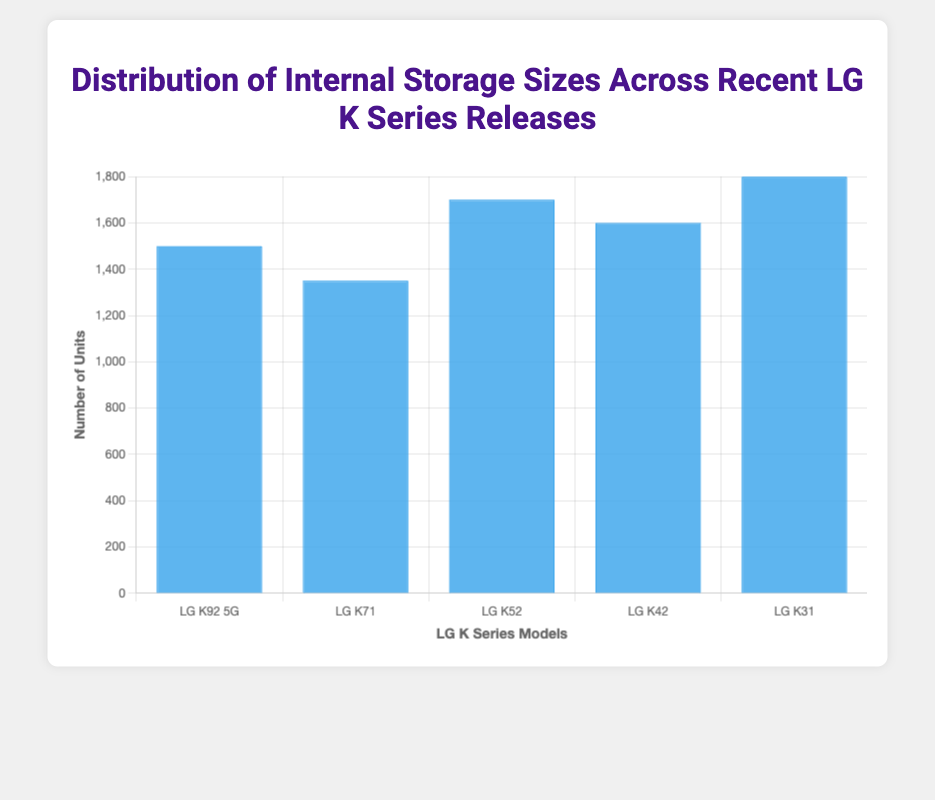Which LG K Series model has the highest number of units with a specific internal storage size? Looking at the height of the bars, the LG K31 with 32GB storage has the highest number of units at 1800.
Answer: LG K31 What is the total number of units for all recent LG K Series releases? Sum the counts of each model: 1500 (LG K92 5G) + 1350 (LG K71) + 1700 (LG K52) + 1600 (LG K42) + 1800 (LG K31) = 7950.
Answer: 7950 Which model has more units, the LG K52 with 64GB storage or the LG K92 5G with 128GB storage? Comparing the two counts, the LG K52 has 1700 units, and the LG K92 5G has 1500 units. Therefore, the LG K52 has more units.
Answer: LG K52 How many more units does the LG K31 have compared to the LG K71? Subtract the count of LG K71 from the count of LG K31: 1800 - 1350 = 450.
Answer: 450 What is the average number of units across all the LG K Series models? Sum the units for all models and divide by the number of models: (1500 + 1350 + 1700 + 1600 + 1800) / 5 = 7950 / 5 = 1590.
Answer: 1590 Which storage size has the most units across all models? Check the count of each storage size: 
- 128GB (LG K92 5G and LG K71): 1500 + 1350 = 2850 
- 64GB (LG K52 and LG K42): 1700 + 1600 = 3300 
- 32GB (LG K31): 1800. The 64GB storage size has the most units at 3300.
Answer: 64GB Is there a model with double or more units compared to another model? Compare each model's count to see if any have at least double the units of another:
- LG K31 (1800) compared to LG K71 (1350): 1800 is not double 1350.
- LG K52 (1700) compared to LG K92 5G (1500): 1700 is not double 1500.
- Continue similar comparisons for all models. There is no model with double or more units compared to any other model.
Answer: No 